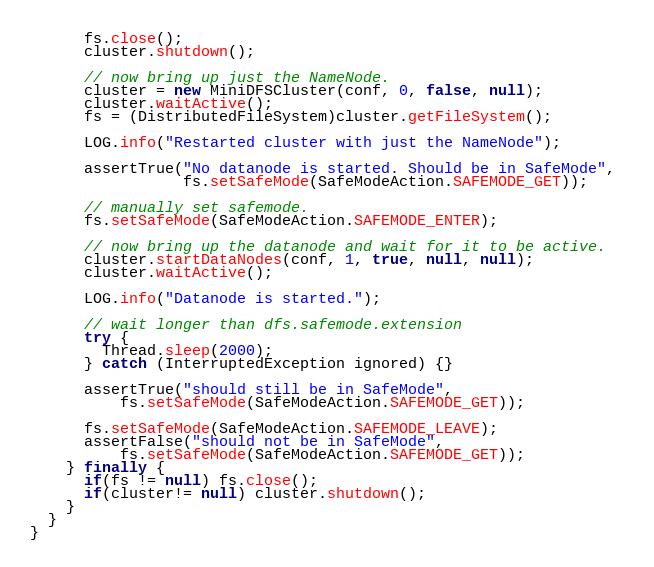<code> <loc_0><loc_0><loc_500><loc_500><_Java_>      fs.close();
      cluster.shutdown();
      
      // now bring up just the NameNode.
      cluster = new MiniDFSCluster(conf, 0, false, null);
      cluster.waitActive();
      fs = (DistributedFileSystem)cluster.getFileSystem();
      
      LOG.info("Restarted cluster with just the NameNode");
      
      assertTrue("No datanode is started. Should be in SafeMode", 
                 fs.setSafeMode(SafeModeAction.SAFEMODE_GET));
      
      // manually set safemode.
      fs.setSafeMode(SafeModeAction.SAFEMODE_ENTER);
      
      // now bring up the datanode and wait for it to be active.
      cluster.startDataNodes(conf, 1, true, null, null);
      cluster.waitActive();
      
      LOG.info("Datanode is started.");

      // wait longer than dfs.safemode.extension
      try {
        Thread.sleep(2000);
      } catch (InterruptedException ignored) {}
      
      assertTrue("should still be in SafeMode",
          fs.setSafeMode(SafeModeAction.SAFEMODE_GET));
      
      fs.setSafeMode(SafeModeAction.SAFEMODE_LEAVE);
      assertFalse("should not be in SafeMode",
          fs.setSafeMode(SafeModeAction.SAFEMODE_GET));
    } finally {
      if(fs != null) fs.close();
      if(cluster!= null) cluster.shutdown();
    }
  }
}
</code> 